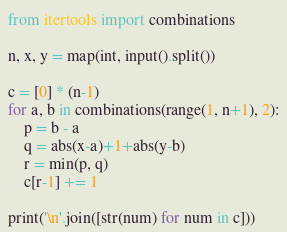Convert code to text. <code><loc_0><loc_0><loc_500><loc_500><_Python_>from itertools import combinations

n, x, y = map(int, input().split())

c = [0] * (n-1)
for a, b in combinations(range(1, n+1), 2):
    p = b - a
    q = abs(x-a)+1+abs(y-b)
    r = min(p, q)
    c[r-1] += 1

print('\n'.join([str(num) for num in c]))
</code> 